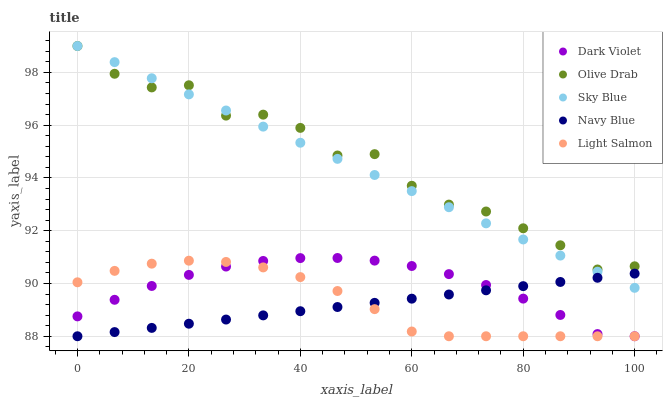Does Navy Blue have the minimum area under the curve?
Answer yes or no. Yes. Does Olive Drab have the maximum area under the curve?
Answer yes or no. Yes. Does Light Salmon have the minimum area under the curve?
Answer yes or no. No. Does Light Salmon have the maximum area under the curve?
Answer yes or no. No. Is Navy Blue the smoothest?
Answer yes or no. Yes. Is Olive Drab the roughest?
Answer yes or no. Yes. Is Light Salmon the smoothest?
Answer yes or no. No. Is Light Salmon the roughest?
Answer yes or no. No. Does Light Salmon have the lowest value?
Answer yes or no. Yes. Does Olive Drab have the lowest value?
Answer yes or no. No. Does Olive Drab have the highest value?
Answer yes or no. Yes. Does Light Salmon have the highest value?
Answer yes or no. No. Is Dark Violet less than Olive Drab?
Answer yes or no. Yes. Is Olive Drab greater than Navy Blue?
Answer yes or no. Yes. Does Light Salmon intersect Navy Blue?
Answer yes or no. Yes. Is Light Salmon less than Navy Blue?
Answer yes or no. No. Is Light Salmon greater than Navy Blue?
Answer yes or no. No. Does Dark Violet intersect Olive Drab?
Answer yes or no. No. 